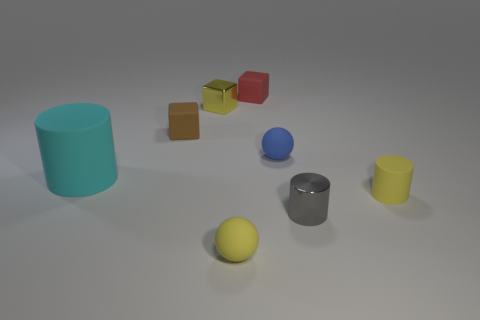What size is the cylinder that is both on the left side of the tiny yellow cylinder and behind the small gray metallic cylinder?
Make the answer very short. Large. What number of red rubber objects are the same size as the blue object?
Offer a very short reply. 1. How many matte objects are tiny yellow blocks or big objects?
Ensure brevity in your answer.  1. The cylinder that is the same color as the metal cube is what size?
Provide a short and direct response. Small. There is a small yellow thing on the right side of the blue rubber sphere that is on the right side of the yellow metallic block; what is it made of?
Keep it short and to the point. Rubber. How many things are green cubes or matte balls left of the red object?
Your answer should be very brief. 1. What size is the cyan thing that is the same material as the blue sphere?
Offer a very short reply. Large. How many yellow objects are tiny rubber spheres or tiny matte cylinders?
Offer a terse response. 2. There is a tiny shiny thing that is the same color as the small matte cylinder; what is its shape?
Provide a succinct answer. Cube. Is there any other thing that is the same material as the small yellow ball?
Ensure brevity in your answer.  Yes. 